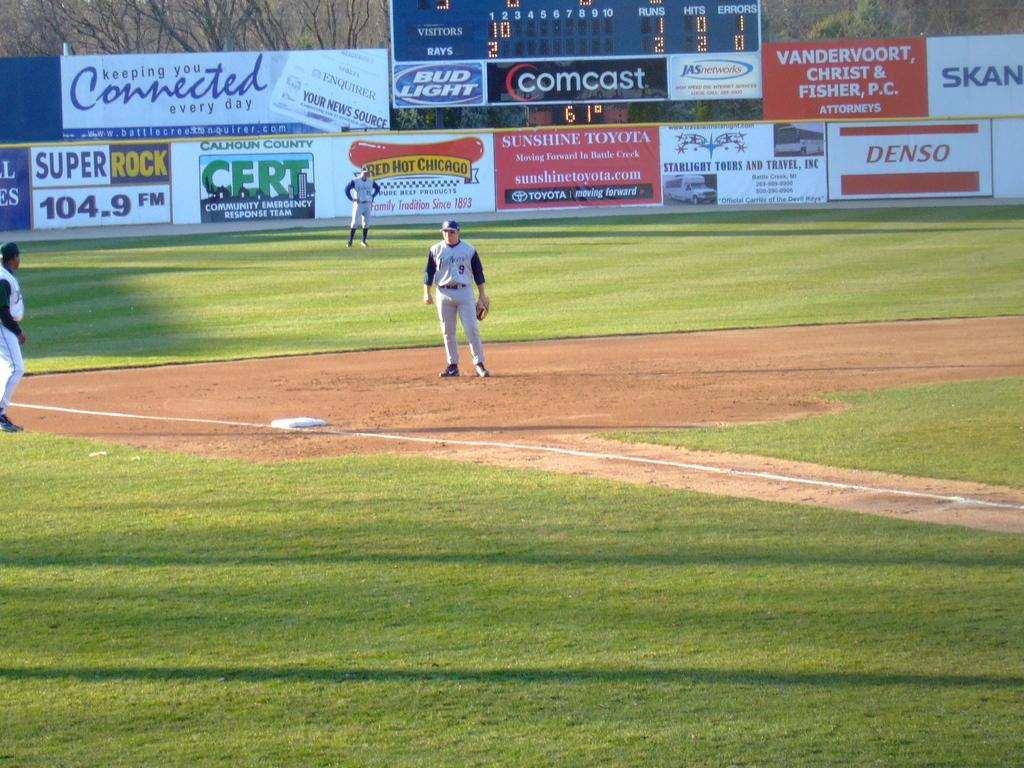<image>
Present a compact description of the photo's key features. A baseball field with players on it and advertisements for Super Rock radio station, Comcast, and Toyota, as well as other businesses. 